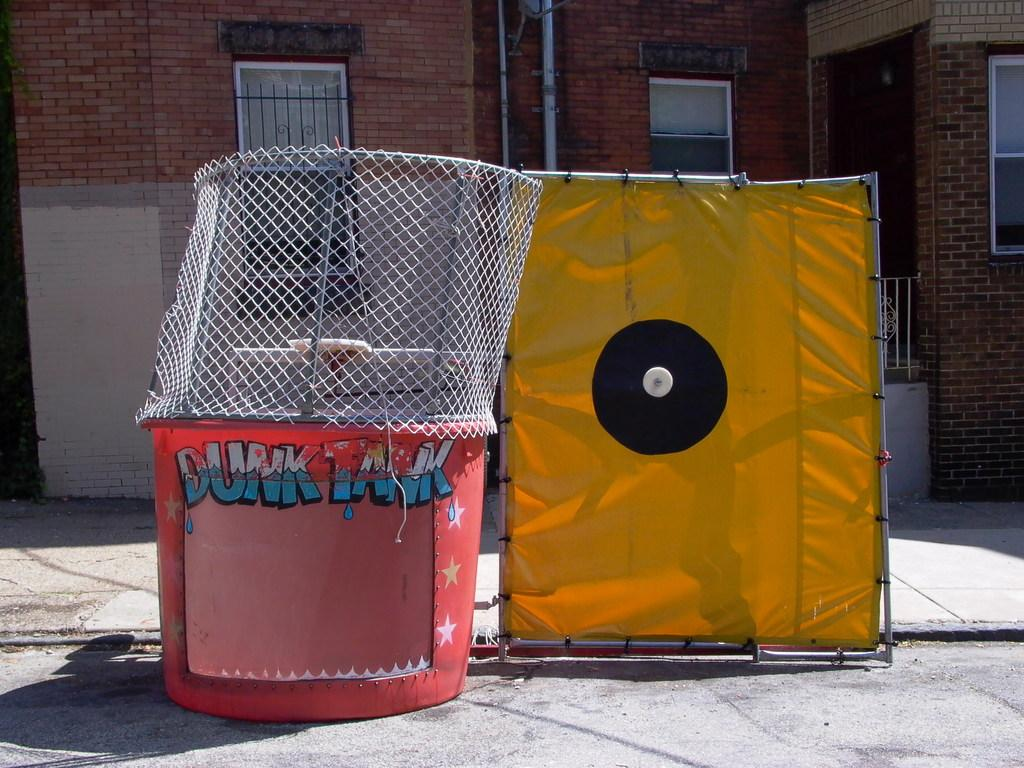<image>
Create a compact narrative representing the image presented. A red DUNK TANK sits next to the yellow and black ball target. 